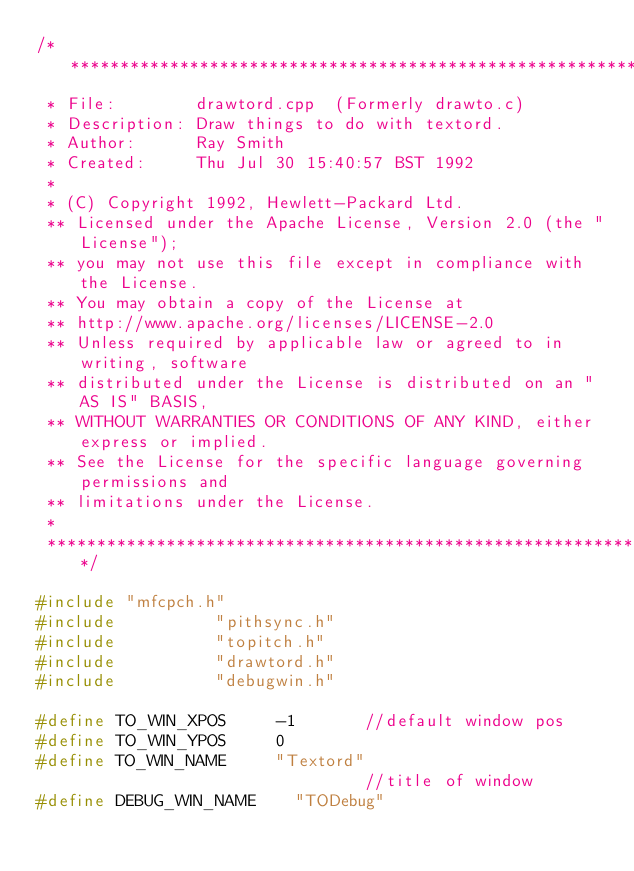Convert code to text. <code><loc_0><loc_0><loc_500><loc_500><_C++_>/**********************************************************************
 * File:        drawtord.cpp  (Formerly drawto.c)
 * Description: Draw things to do with textord.
 * Author:		Ray Smith
 * Created:		Thu Jul 30 15:40:57 BST 1992
 *
 * (C) Copyright 1992, Hewlett-Packard Ltd.
 ** Licensed under the Apache License, Version 2.0 (the "License");
 ** you may not use this file except in compliance with the License.
 ** You may obtain a copy of the License at
 ** http://www.apache.org/licenses/LICENSE-2.0
 ** Unless required by applicable law or agreed to in writing, software
 ** distributed under the License is distributed on an "AS IS" BASIS,
 ** WITHOUT WARRANTIES OR CONDITIONS OF ANY KIND, either express or implied.
 ** See the License for the specific language governing permissions and
 ** limitations under the License.
 *
 **********************************************************************/

#include "mfcpch.h"
#include          "pithsync.h"
#include          "topitch.h"
#include          "drawtord.h"
#include          "debugwin.h"

#define TO_WIN_XPOS     -1       //default window pos
#define TO_WIN_YPOS     0
#define TO_WIN_NAME     "Textord"
                                 //title of window
#define DEBUG_WIN_NAME    "TODebug"</code> 